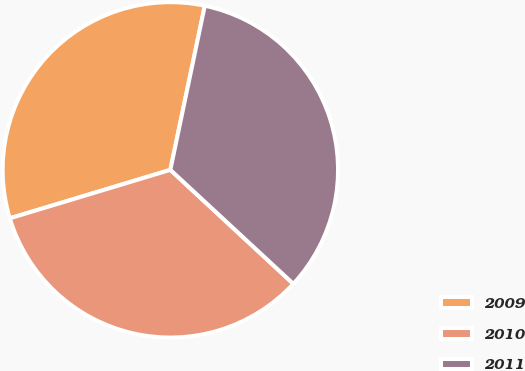Convert chart to OTSL. <chart><loc_0><loc_0><loc_500><loc_500><pie_chart><fcel>2009<fcel>2010<fcel>2011<nl><fcel>32.96%<fcel>33.44%<fcel>33.6%<nl></chart> 